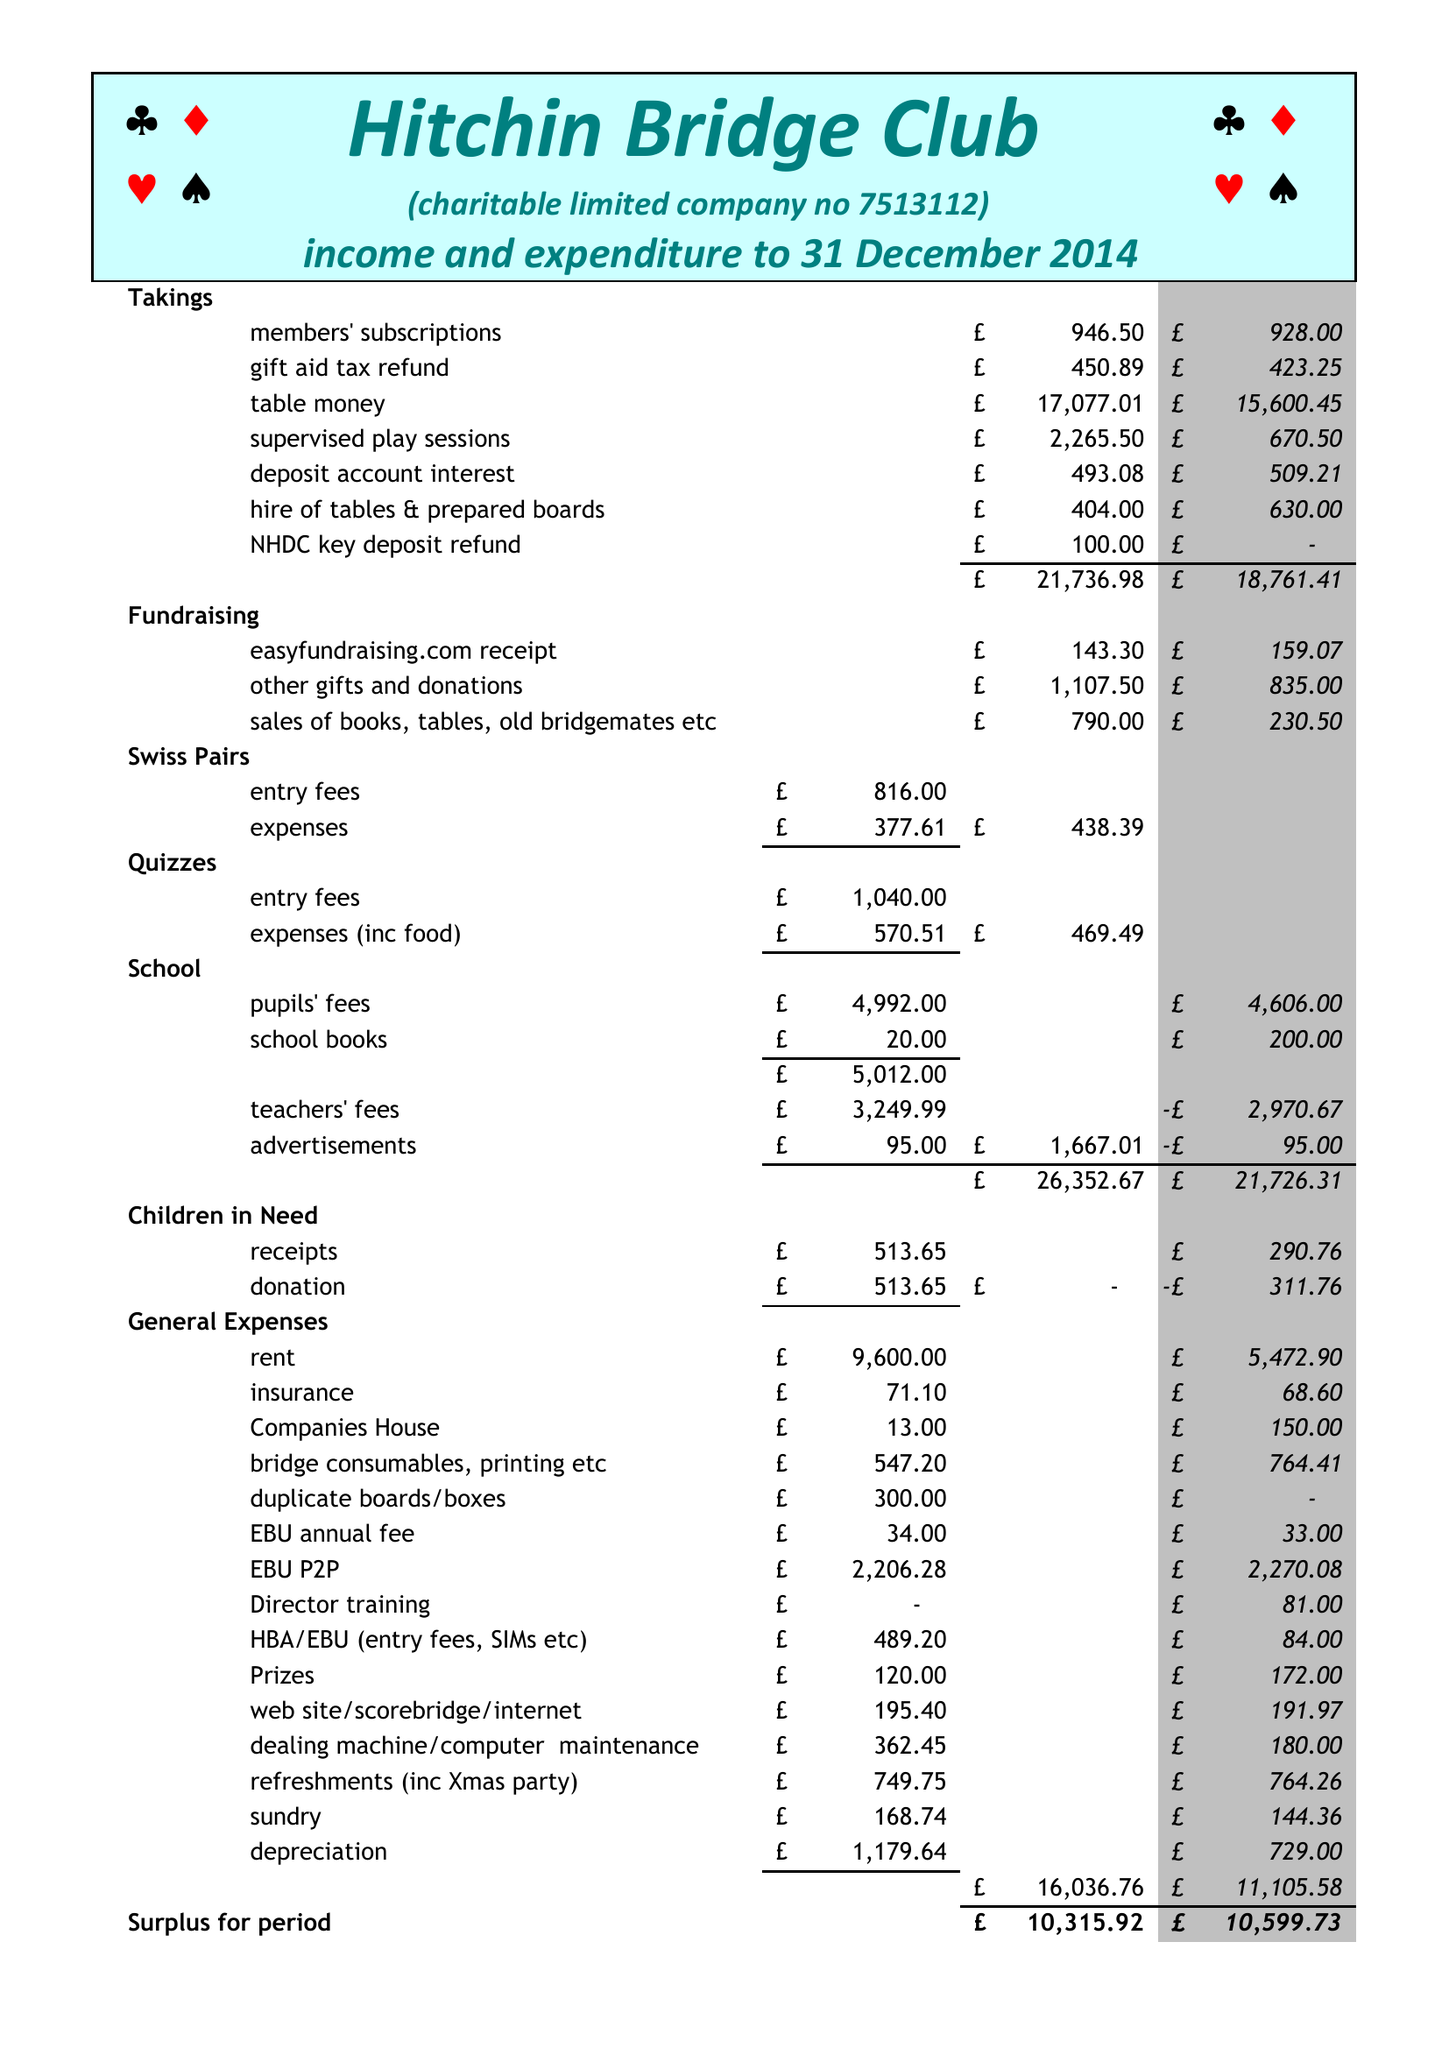What is the value for the income_annually_in_british_pounds?
Answer the question using a single word or phrase. 26352.67 